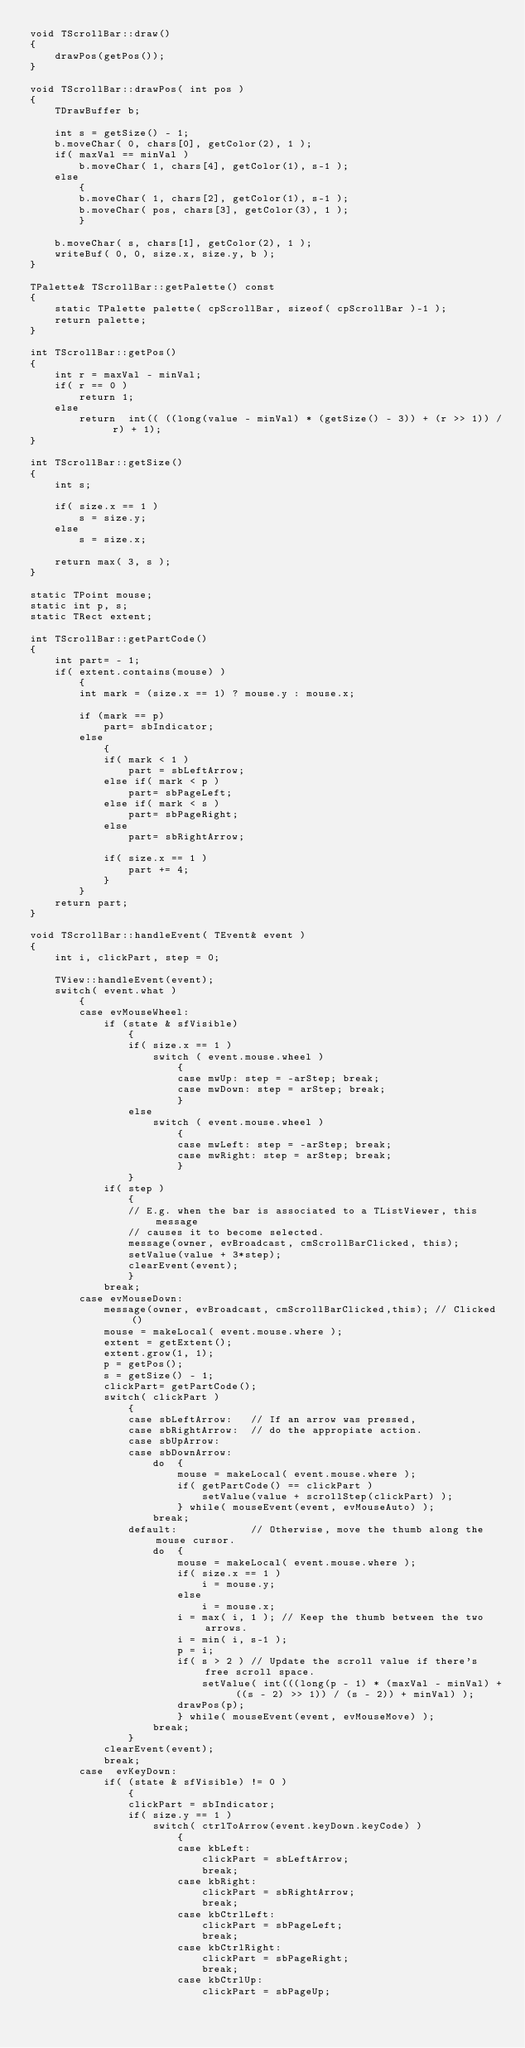Convert code to text. <code><loc_0><loc_0><loc_500><loc_500><_C++_>void TScrollBar::draw()
{
    drawPos(getPos());
}

void TScrollBar::drawPos( int pos )
{
    TDrawBuffer b;

    int s = getSize() - 1;
    b.moveChar( 0, chars[0], getColor(2), 1 );
    if( maxVal == minVal )
        b.moveChar( 1, chars[4], getColor(1), s-1 );
    else
        {
        b.moveChar( 1, chars[2], getColor(1), s-1 );
        b.moveChar( pos, chars[3], getColor(3), 1 );
        }

    b.moveChar( s, chars[1], getColor(2), 1 );
    writeBuf( 0, 0, size.x, size.y, b );
}

TPalette& TScrollBar::getPalette() const
{
    static TPalette palette( cpScrollBar, sizeof( cpScrollBar )-1 );
    return palette;
}

int TScrollBar::getPos()
{
    int r = maxVal - minVal;
    if( r == 0 )
        return 1;
    else
        return  int(( ((long(value - minVal) * (getSize() - 3)) + (r >> 1)) / r) + 1);
}

int TScrollBar::getSize()
{
    int s;

    if( size.x == 1 )
        s = size.y;
    else
        s = size.x;

    return max( 3, s );
}

static TPoint mouse;
static int p, s;
static TRect extent;

int TScrollBar::getPartCode()
{
    int part= - 1;
    if( extent.contains(mouse) )
        {
        int mark = (size.x == 1) ? mouse.y : mouse.x;

        if (mark == p)
            part= sbIndicator;
        else
            {
            if( mark < 1 )
                part = sbLeftArrow;
            else if( mark < p )
                part= sbPageLeft;
            else if( mark < s )
                part= sbPageRight;
            else
                part= sbRightArrow;

            if( size.x == 1 )
                part += 4;
            }
        }
    return part;
}

void TScrollBar::handleEvent( TEvent& event )
{
    int i, clickPart, step = 0;

    TView::handleEvent(event);
    switch( event.what )
        {
        case evMouseWheel:
            if (state & sfVisible)
                {
                if( size.x == 1 )
                    switch ( event.mouse.wheel )
                        {
                        case mwUp: step = -arStep; break;
                        case mwDown: step = arStep; break;
                        }
                else
                    switch ( event.mouse.wheel )
                        {
                        case mwLeft: step = -arStep; break;
                        case mwRight: step = arStep; break;
                        }
                }
            if( step )
                {
                // E.g. when the bar is associated to a TListViewer, this message
                // causes it to become selected.
                message(owner, evBroadcast, cmScrollBarClicked, this);
                setValue(value + 3*step);
                clearEvent(event);
                }
            break;
        case evMouseDown:
            message(owner, evBroadcast, cmScrollBarClicked,this); // Clicked()
            mouse = makeLocal( event.mouse.where );
            extent = getExtent();
            extent.grow(1, 1);
            p = getPos();
            s = getSize() - 1;
            clickPart= getPartCode();
            switch( clickPart )
                {
                case sbLeftArrow:   // If an arrow was pressed,
                case sbRightArrow:  // do the appropiate action.
                case sbUpArrow:
                case sbDownArrow:
                    do  {
                        mouse = makeLocal( event.mouse.where );
                        if( getPartCode() == clickPart )
                            setValue(value + scrollStep(clickPart) );
                        } while( mouseEvent(event, evMouseAuto) );
                    break;
                default:            // Otherwise, move the thumb along the mouse cursor.
                    do  {
                        mouse = makeLocal( event.mouse.where );
                        if( size.x == 1 )
                            i = mouse.y;
                        else
                            i = mouse.x;
                        i = max( i, 1 ); // Keep the thumb between the two arrows.
                        i = min( i, s-1 );
                        p = i;
                        if( s > 2 ) // Update the scroll value if there's free scroll space.
                            setValue( int(((long(p - 1) * (maxVal - minVal) + ((s - 2) >> 1)) / (s - 2)) + minVal) );
                        drawPos(p);
                        } while( mouseEvent(event, evMouseMove) );
                    break;
                }
            clearEvent(event);
            break;
        case  evKeyDown:
            if( (state & sfVisible) != 0 )
                {
                clickPart = sbIndicator;
                if( size.y == 1 )
                    switch( ctrlToArrow(event.keyDown.keyCode) )
                        {
                        case kbLeft:
                            clickPart = sbLeftArrow;
                            break;
                        case kbRight:
                            clickPart = sbRightArrow;
                            break;
                        case kbCtrlLeft:
                            clickPart = sbPageLeft;
                            break;
                        case kbCtrlRight:
                            clickPart = sbPageRight;
                            break;
                        case kbCtrlUp:
                            clickPart = sbPageUp;</code> 